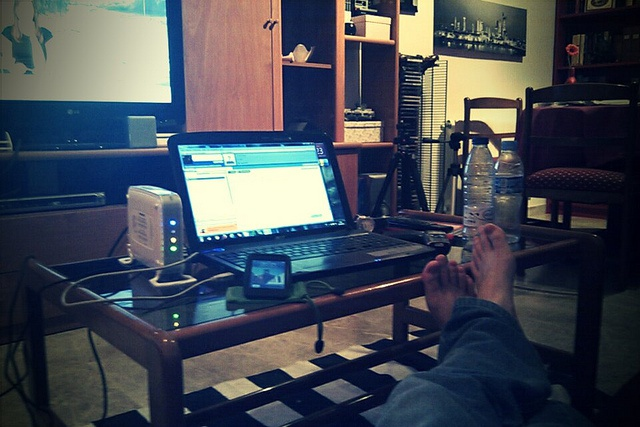Describe the objects in this image and their specific colors. I can see laptop in black, lightyellow, navy, blue, and turquoise tones, tv in black, darkgray, gray, darkblue, and beige tones, people in black, navy, purple, and blue tones, chair in black, gray, and purple tones, and chair in black and khaki tones in this image. 